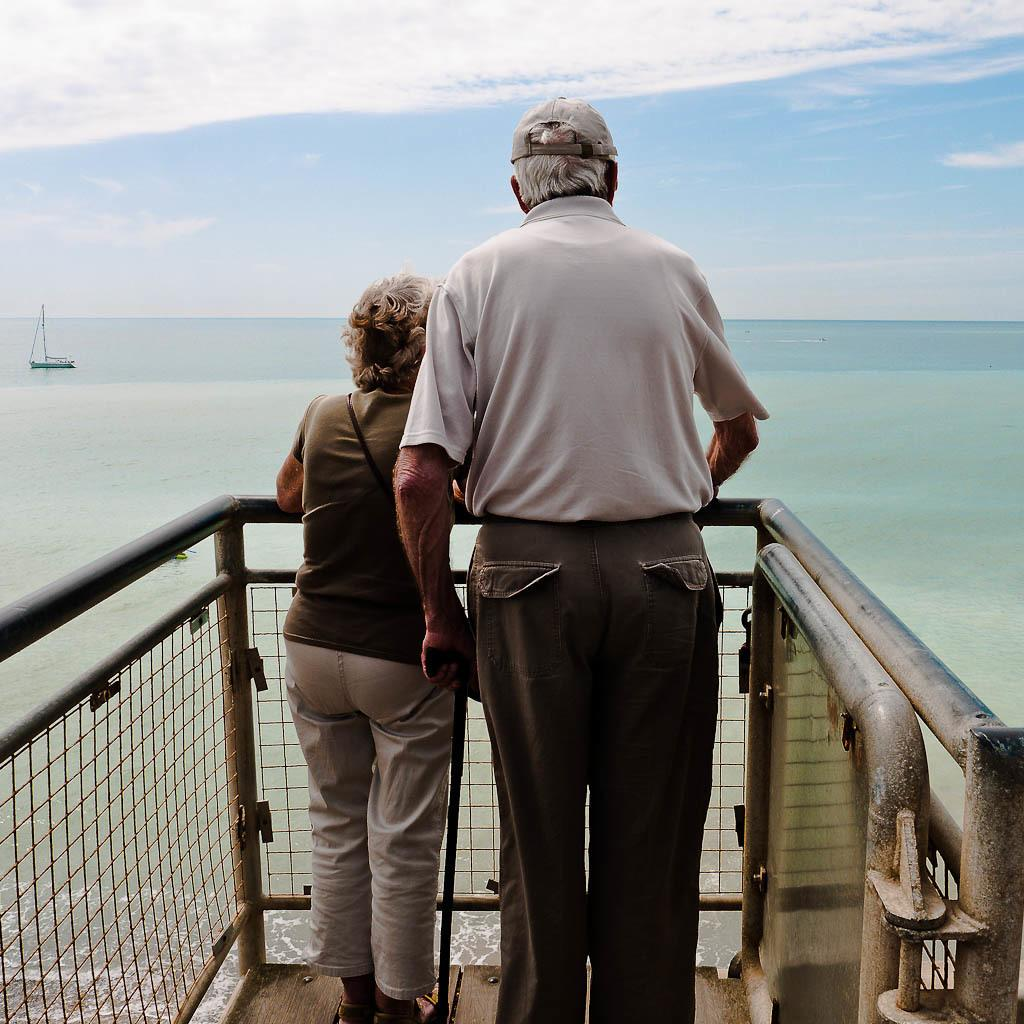How many people are in the image? There are two people in the image. Where are the people standing? The people are standing on a bridge. What is in front of the bridge? There is a river in front of the bridge. What is on the water? There is a boat on the water. What can be seen in the background of the image? The sky is visible in the background of the image. What scientific discovery can be heard in the voice of the people in the image? There is no voice present in the image, and therefore no scientific discovery can be heard. 